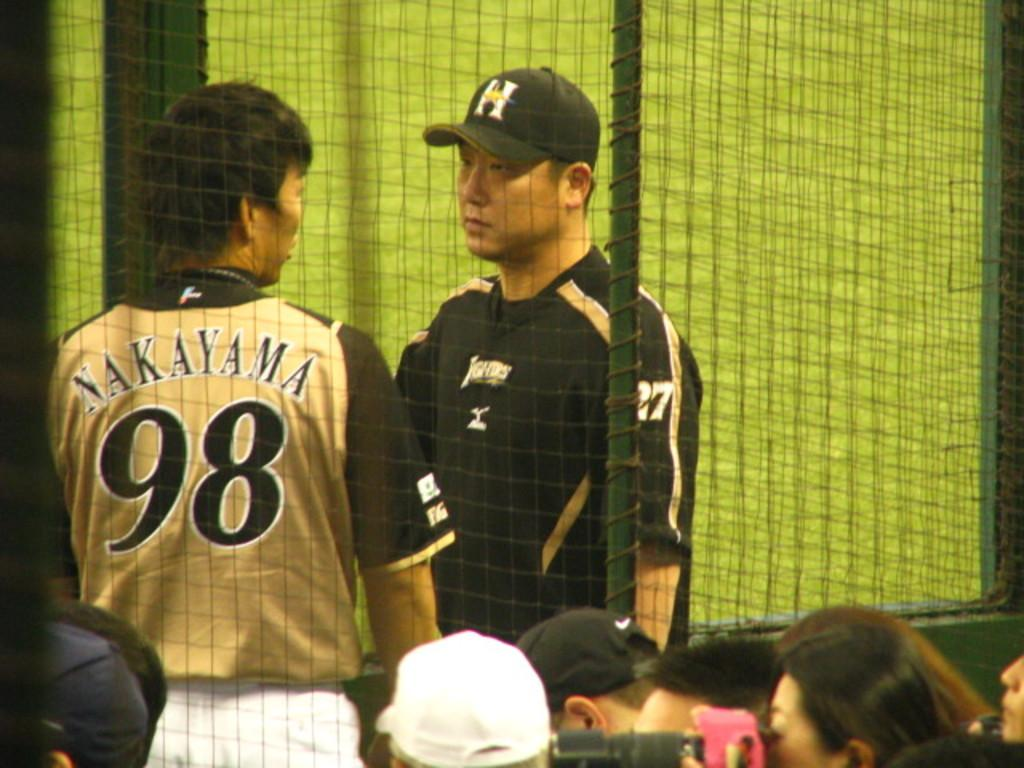Provide a one-sentence caption for the provided image. Number 98 and number 27 talk in front of the fans. 